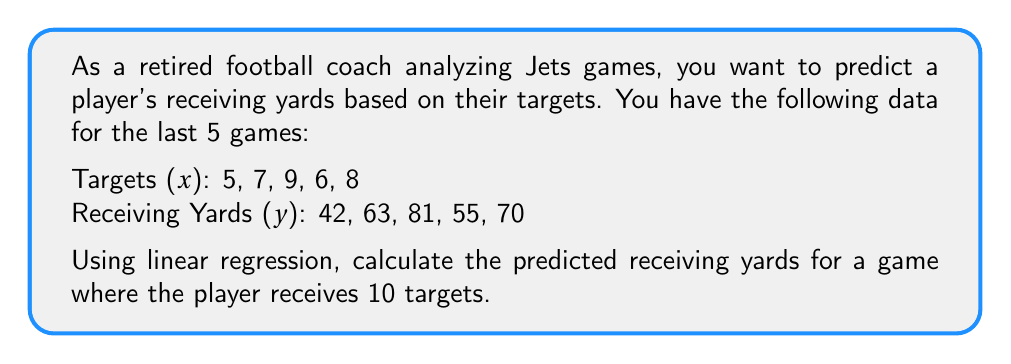What is the answer to this math problem? 1. First, we need to find the slope (m) and y-intercept (b) of the linear regression line $y = mx + b$.

2. To calculate the slope (m), we use the formula:
   $$m = \frac{n\sum xy - \sum x \sum y}{n\sum x^2 - (\sum x)^2}$$

   Where n = 5 (number of data points)
   $\sum x = 5 + 7 + 9 + 6 + 8 = 35$
   $\sum y = 42 + 63 + 81 + 55 + 70 = 311$
   $\sum xy = 5(42) + 7(63) + 9(81) + 6(55) + 8(70) = 2233$
   $\sum x^2 = 5^2 + 7^2 + 9^2 + 6^2 + 8^2 = 255$

3. Substituting these values:
   $$m = \frac{5(2233) - 35(311)}{5(255) - 35^2} = \frac{11165 - 10885}{1275 - 1225} = \frac{280}{50} = 5.6$$

4. To find the y-intercept (b), we use the formula:
   $$b = \bar{y} - m\bar{x}$$

   Where $\bar{x} = \frac{\sum x}{n} = \frac{35}{5} = 7$ and $\bar{y} = \frac{\sum y}{n} = \frac{311}{5} = 62.2$

5. Substituting these values:
   $$b = 62.2 - 5.6(7) = 62.2 - 39.2 = 23$$

6. Our linear regression equation is:
   $$y = 5.6x + 23$$

7. To predict the receiving yards for 10 targets, we substitute x = 10:
   $$y = 5.6(10) + 23 = 56 + 23 = 79$$
Answer: 79 yards 